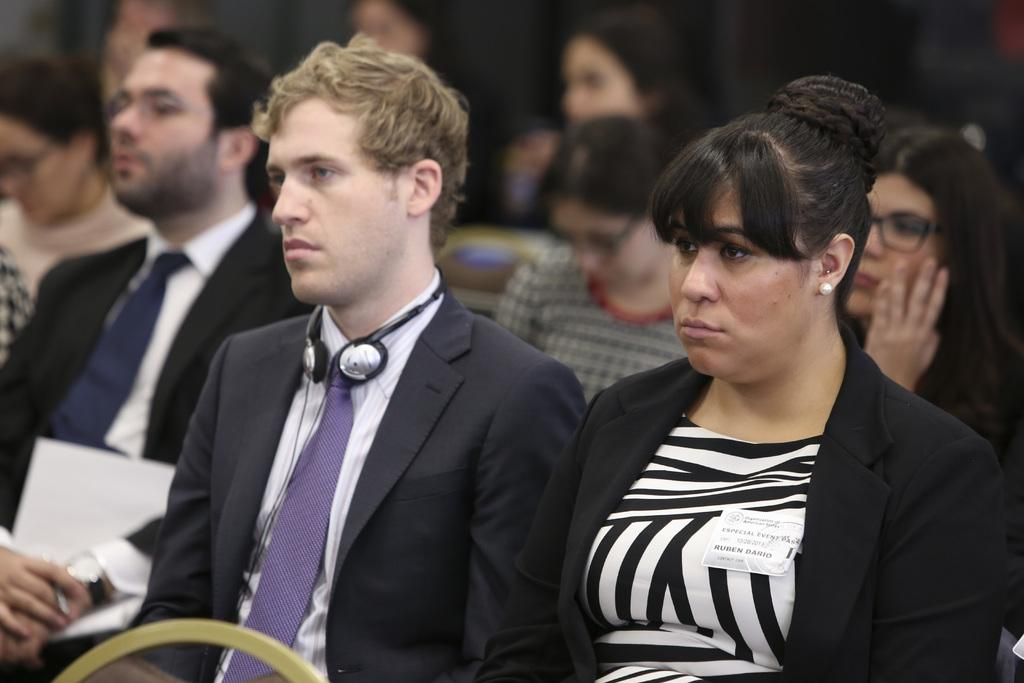What are the people in the image doing? The people in the image are sitting on chairs. Can you describe any objects that the people are holding or wearing? One person is holding a paper in their hand, and one man is wearing headphones around his neck. How many kittens can be seen playing with the paper in the image? There are no kittens present in the image. 